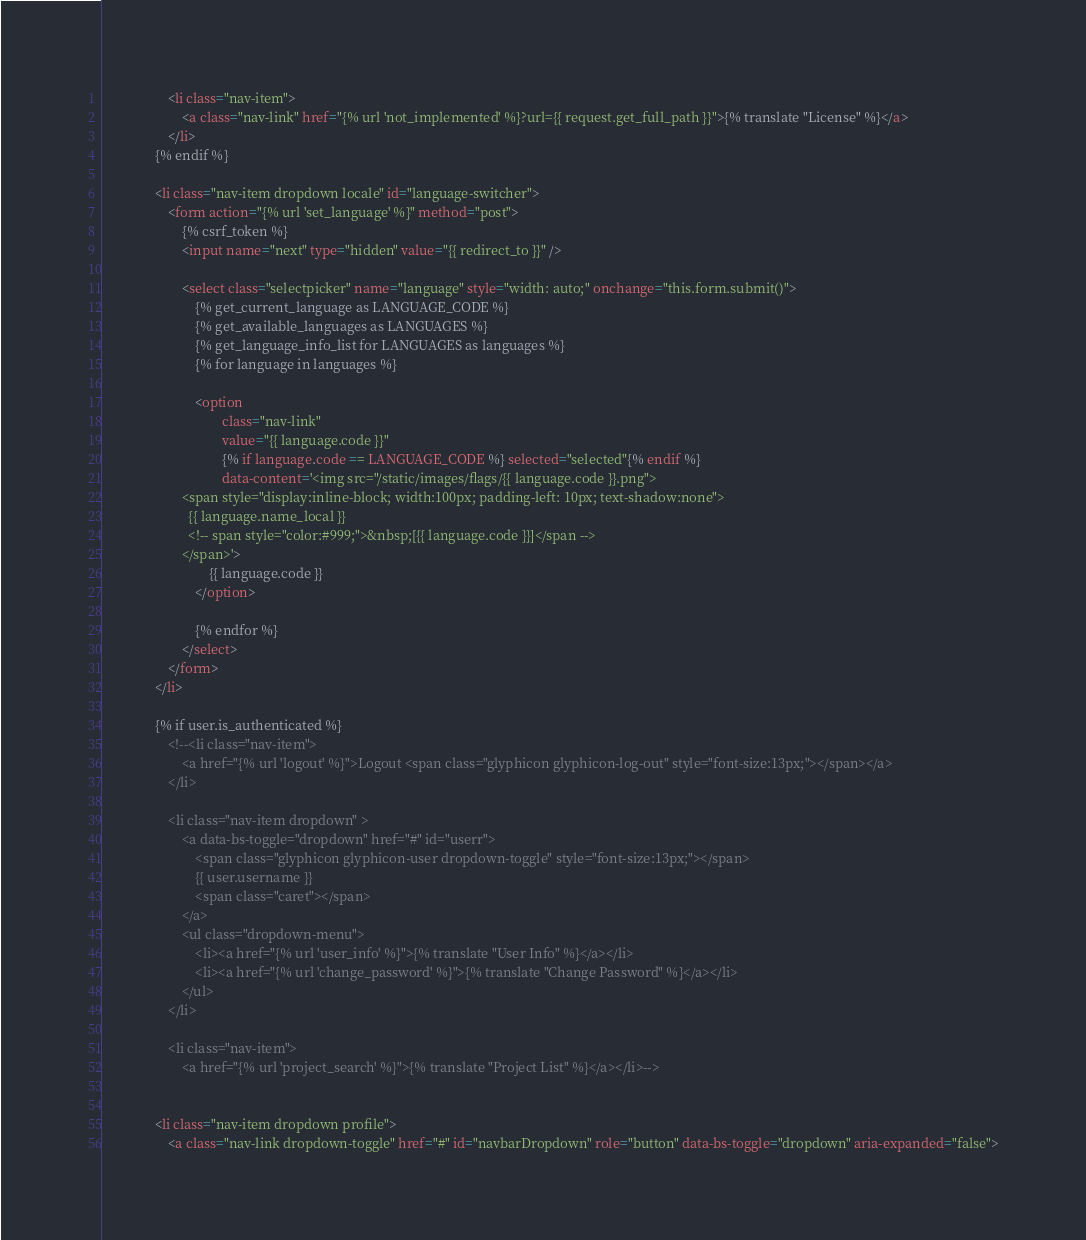<code> <loc_0><loc_0><loc_500><loc_500><_HTML_>                    <li class="nav-item">
                        <a class="nav-link" href="{% url 'not_implemented' %}?url={{ request.get_full_path }}">{% translate "License" %}</a>
                    </li>
                {% endif %}

                <li class="nav-item dropdown locale" id="language-switcher">
                    <form action="{% url 'set_language' %}" method="post">
                        {% csrf_token %}
                        <input name="next" type="hidden" value="{{ redirect_to }}" />

                        <select class="selectpicker" name="language" style="width: auto;" onchange="this.form.submit()">
                            {% get_current_language as LANGUAGE_CODE %}
                            {% get_available_languages as LANGUAGES %}
                            {% get_language_info_list for LANGUAGES as languages %}
                            {% for language in languages %}

                            <option
                                    class="nav-link"
                                    value="{{ language.code }}"
                                    {% if language.code == LANGUAGE_CODE %} selected="selected"{% endif %}
                                    data-content='<img src="/static/images/flags/{{ language.code }}.png">
                        <span style="display:inline-block; width:100px; padding-left: 10px; text-shadow:none">
                          {{ language.name_local }}
                          <!-- span style="color:#999;">&nbsp;[{{ language.code }}]</span -->
                        </span>'>
                                {{ language.code }}
                            </option>

                            {% endfor %}
                        </select>
                    </form>
                </li>

                {% if user.is_authenticated %}
                    <!--<li class="nav-item">
                        <a href="{% url 'logout' %}">Logout <span class="glyphicon glyphicon-log-out" style="font-size:13px;"></span></a>
                    </li>

                    <li class="nav-item dropdown" >
                        <a data-bs-toggle="dropdown" href="#" id="userr">
                            <span class="glyphicon glyphicon-user dropdown-toggle" style="font-size:13px;"></span>
                            {{ user.username }}
                            <span class="caret"></span>
                        </a>
                        <ul class="dropdown-menu">
                            <li><a href="{% url 'user_info' %}">{% translate "User Info" %}</a></li>
                            <li><a href="{% url 'change_password' %}">{% translate "Change Password" %}</a></li>
                        </ul>
                    </li>

                    <li class="nav-item">
                        <a href="{% url 'project_search' %}">{% translate "Project List" %}</a></li>-->


                <li class="nav-item dropdown profile">
                    <a class="nav-link dropdown-toggle" href="#" id="navbarDropdown" role="button" data-bs-toggle="dropdown" aria-expanded="false"></code> 